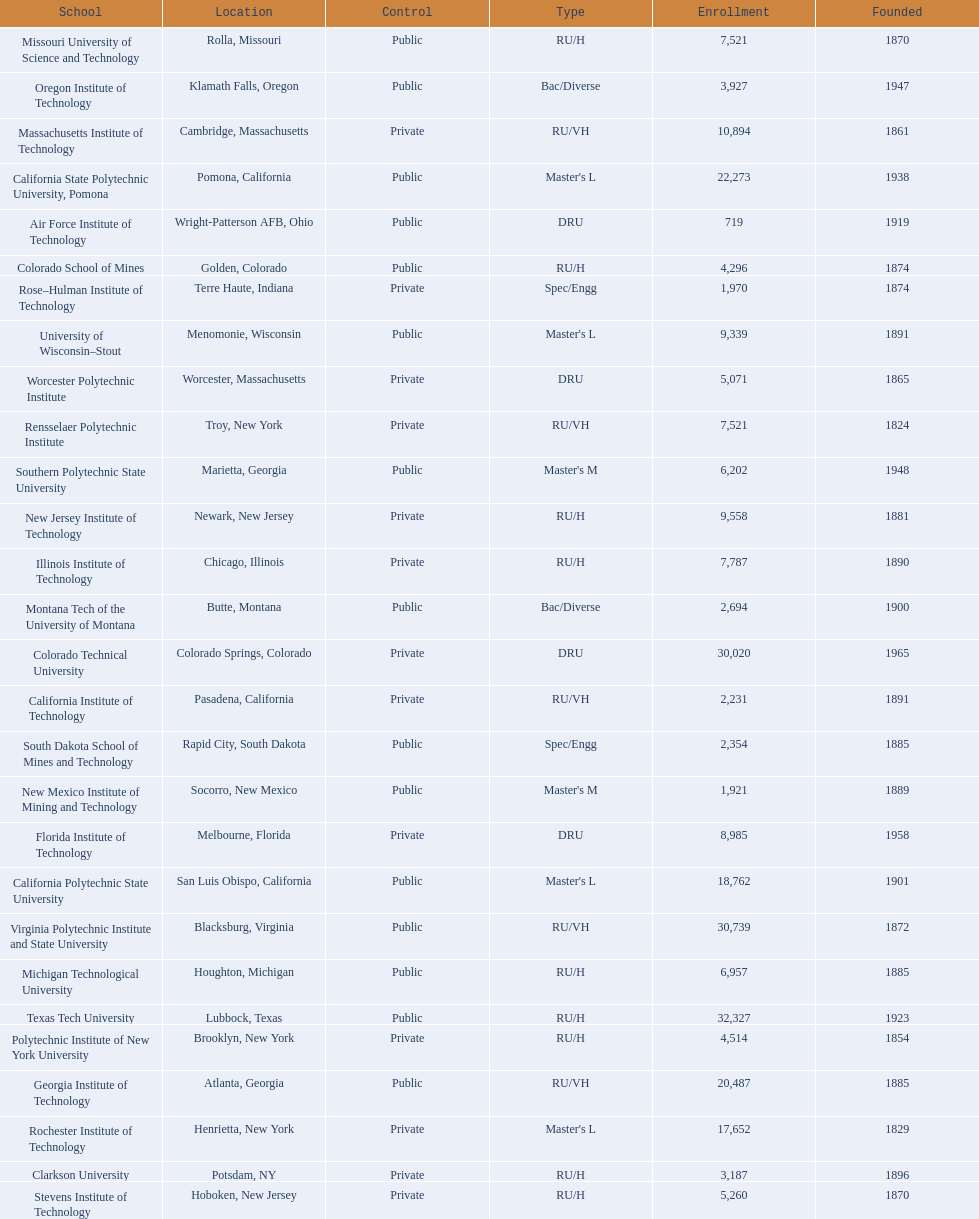What technical universities are in the united states? Air Force Institute of Technology, California Institute of Technology, California Polytechnic State University, California State Polytechnic University, Pomona, Clarkson University, Colorado School of Mines, Colorado Technical University, Florida Institute of Technology, Georgia Institute of Technology, Illinois Institute of Technology, Massachusetts Institute of Technology, Michigan Technological University, Missouri University of Science and Technology, Montana Tech of the University of Montana, New Jersey Institute of Technology, New Mexico Institute of Mining and Technology, Oregon Institute of Technology, Polytechnic Institute of New York University, Rensselaer Polytechnic Institute, Rochester Institute of Technology, Rose–Hulman Institute of Technology, South Dakota School of Mines and Technology, Southern Polytechnic State University, Stevens Institute of Technology, Texas Tech University, University of Wisconsin–Stout, Virginia Polytechnic Institute and State University, Worcester Polytechnic Institute. Which has the highest enrollment? Texas Tech University. 